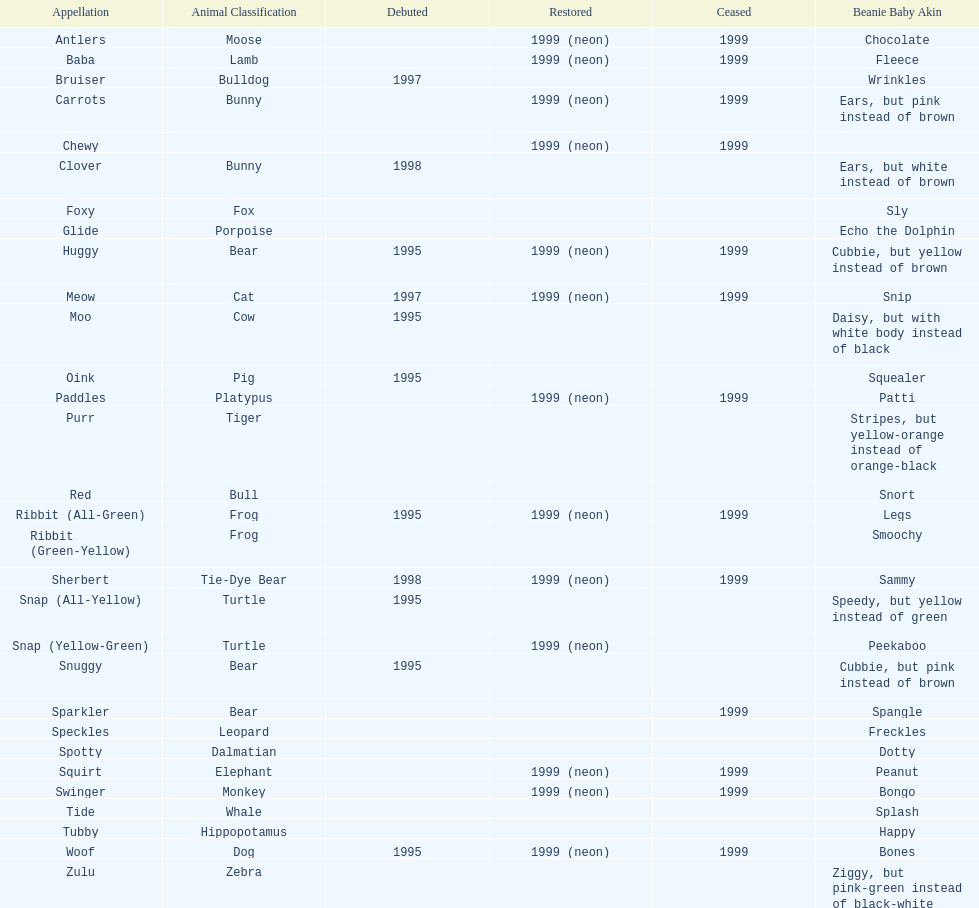What is the name of the pillow pal listed after clover? Foxy. 